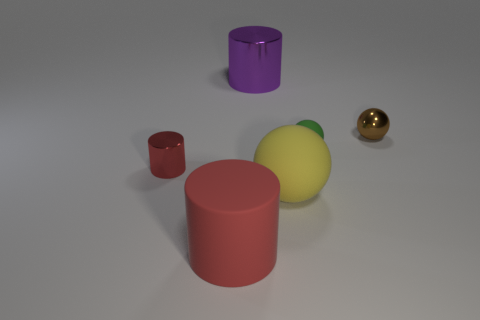What material is the other ball that is the same size as the metal sphere?
Keep it short and to the point. Rubber. What is the color of the small thing left of the large rubber object on the right side of the thing that is in front of the big yellow rubber thing?
Ensure brevity in your answer.  Red. There is a small metallic object right of the tiny red cylinder; does it have the same shape as the large matte thing to the left of the purple metallic cylinder?
Provide a succinct answer. No. What number of big rubber things are there?
Make the answer very short. 2. There is a cylinder that is the same size as the green matte ball; what color is it?
Your response must be concise. Red. Do the big object left of the large purple thing and the small thing that is in front of the green rubber thing have the same material?
Offer a very short reply. No. There is a purple thing that is to the left of the matte sphere that is behind the tiny red cylinder; how big is it?
Keep it short and to the point. Large. What is the material of the cylinder in front of the red metallic object?
Make the answer very short. Rubber. How many objects are either red things that are in front of the large yellow matte thing or tiny shiny objects on the right side of the large red rubber cylinder?
Offer a terse response. 2. What material is the large red object that is the same shape as the purple shiny thing?
Make the answer very short. Rubber. 